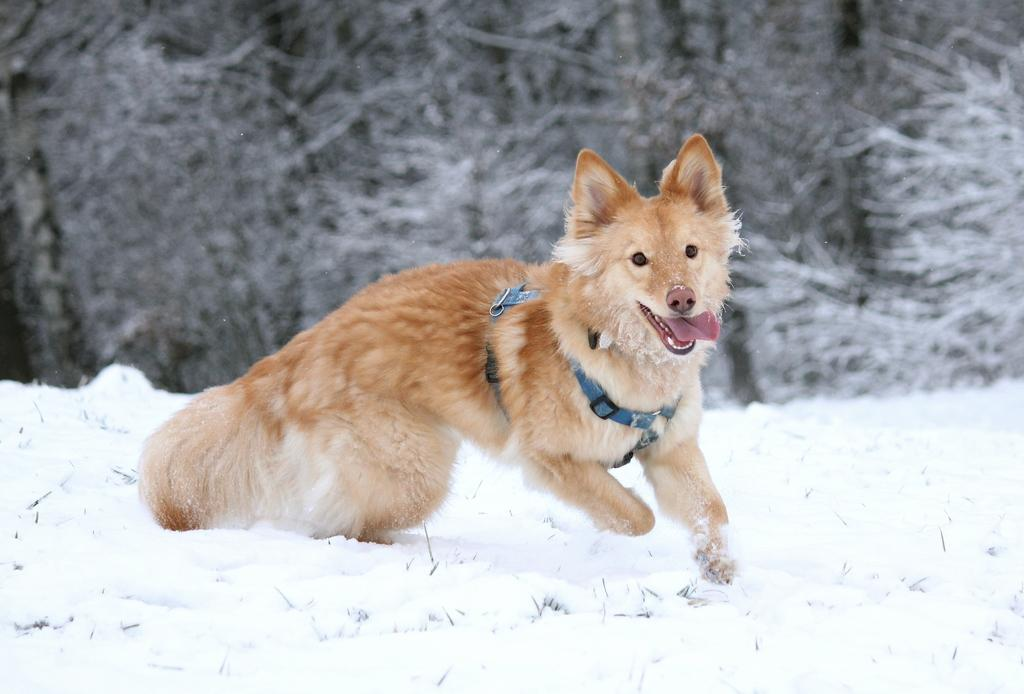What type of animal can be seen in the image? There is a brown color animal in the image. What is the animal doing in the image? The animal is running on the snow. Can you describe the background of the image? The background of the image is blurred. What type of cart is being pulled by the governor in the image? There is no governor or cart present in the image. 